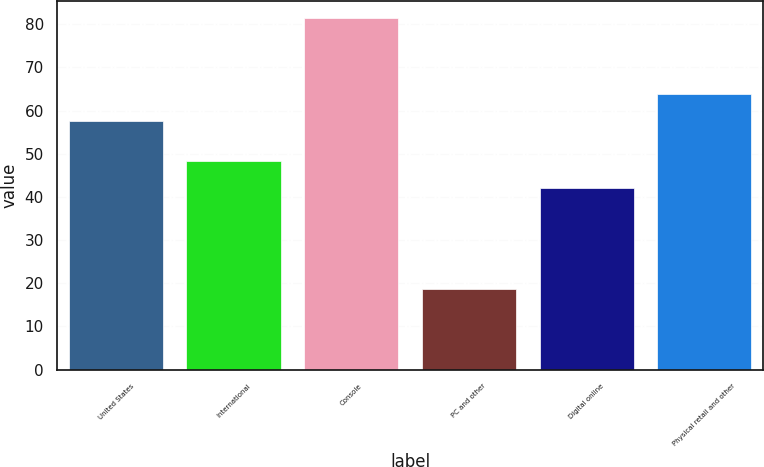Convert chart to OTSL. <chart><loc_0><loc_0><loc_500><loc_500><bar_chart><fcel>United States<fcel>International<fcel>Console<fcel>PC and other<fcel>Digital online<fcel>Physical retail and other<nl><fcel>57.5<fcel>48.28<fcel>81.4<fcel>18.6<fcel>42<fcel>63.78<nl></chart> 